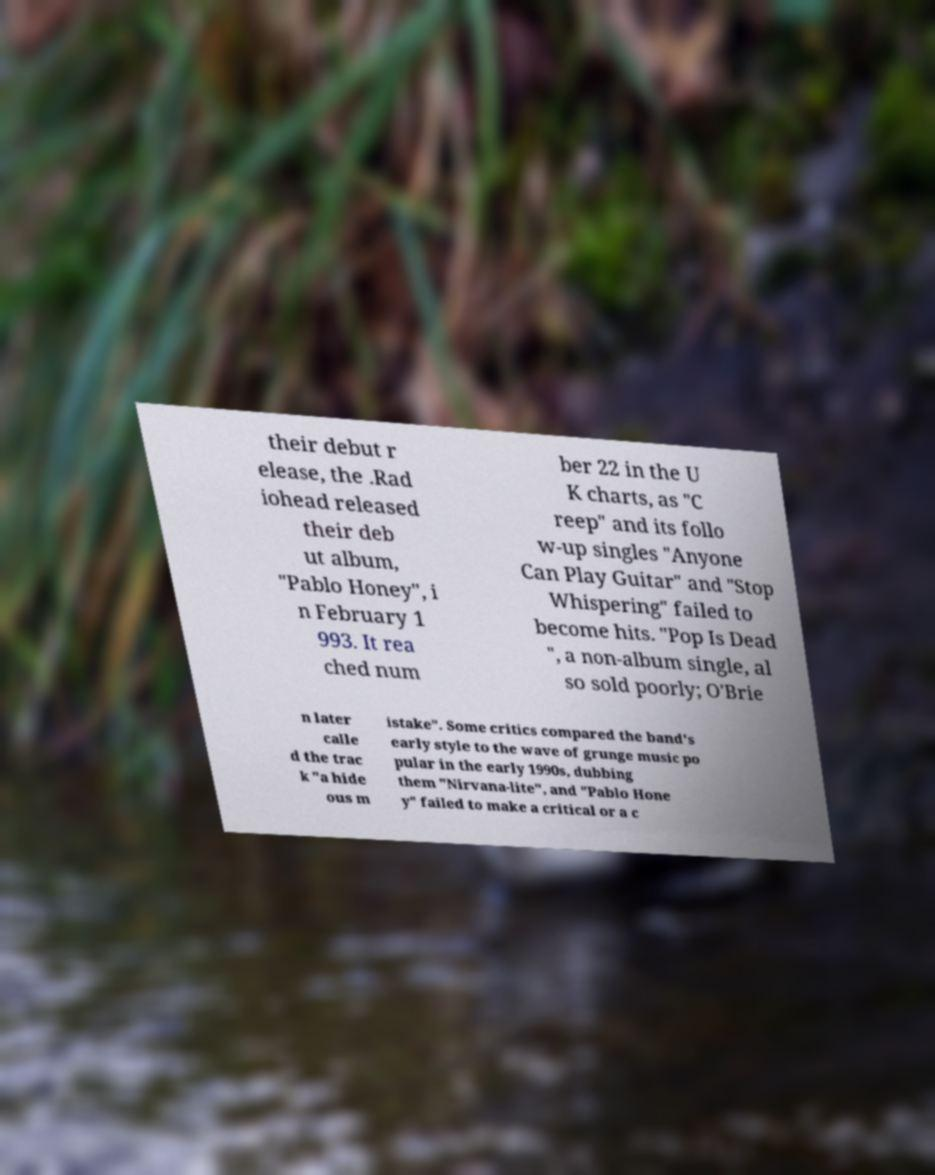Please identify and transcribe the text found in this image. their debut r elease, the .Rad iohead released their deb ut album, "Pablo Honey", i n February 1 993. It rea ched num ber 22 in the U K charts, as "C reep" and its follo w-up singles "Anyone Can Play Guitar" and "Stop Whispering" failed to become hits. "Pop Is Dead ", a non-album single, al so sold poorly; O'Brie n later calle d the trac k "a hide ous m istake". Some critics compared the band's early style to the wave of grunge music po pular in the early 1990s, dubbing them "Nirvana-lite", and "Pablo Hone y" failed to make a critical or a c 